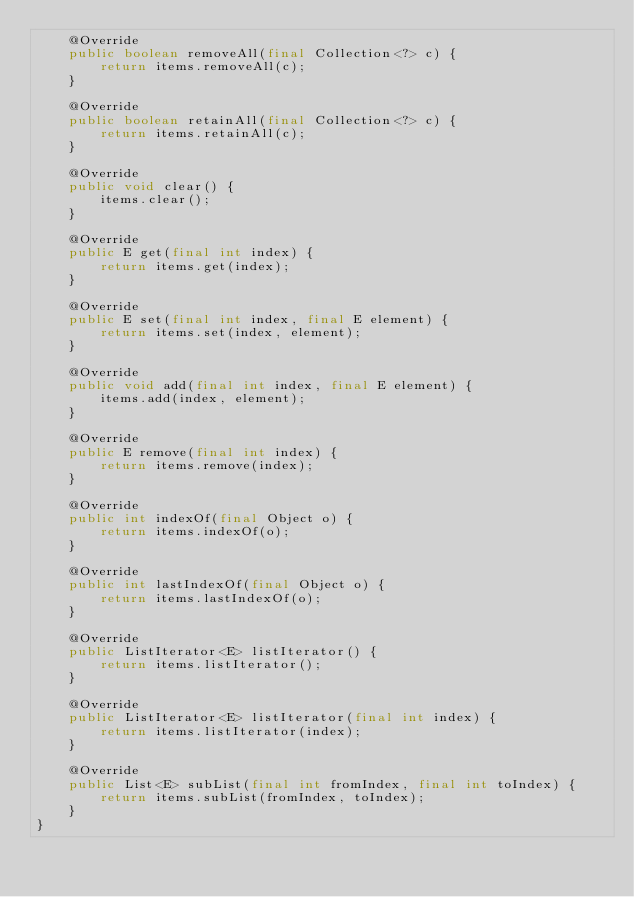<code> <loc_0><loc_0><loc_500><loc_500><_Java_>    @Override
    public boolean removeAll(final Collection<?> c) {
        return items.removeAll(c);
    }

    @Override
    public boolean retainAll(final Collection<?> c) {
        return items.retainAll(c);
    }

    @Override
    public void clear() {
        items.clear();
    }

    @Override
    public E get(final int index) {
        return items.get(index);
    }

    @Override
    public E set(final int index, final E element) {
        return items.set(index, element);
    }

    @Override
    public void add(final int index, final E element) {
        items.add(index, element);
    }

    @Override
    public E remove(final int index) {
        return items.remove(index);
    }

    @Override
    public int indexOf(final Object o) {
        return items.indexOf(o);
    }

    @Override
    public int lastIndexOf(final Object o) {
        return items.lastIndexOf(o);
    }

    @Override
    public ListIterator<E> listIterator() {
        return items.listIterator();
    }

    @Override
    public ListIterator<E> listIterator(final int index) {
        return items.listIterator(index);
    }

    @Override
    public List<E> subList(final int fromIndex, final int toIndex) {
        return items.subList(fromIndex, toIndex);
    }
}
</code> 